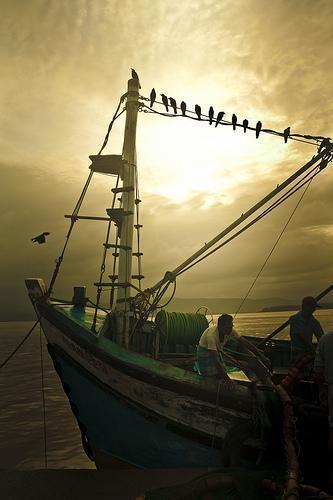How many people are catching fish in the sea?
Give a very brief answer. 0. 